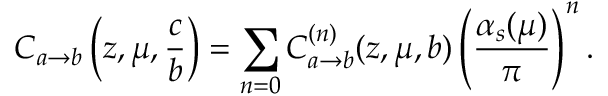Convert formula to latex. <formula><loc_0><loc_0><loc_500><loc_500>C _ { a \rightarrow b } \left ( z , \mu , \frac { c } { b } \right ) = \sum _ { n = 0 } C _ { a \rightarrow b } ^ { ( n ) } ( z , \mu , b ) \left ( \frac { \alpha _ { s } ( \mu ) } { \pi } \right ) ^ { n } .</formula> 